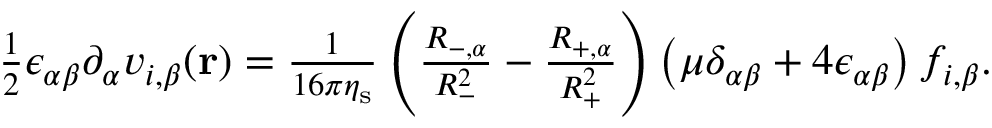<formula> <loc_0><loc_0><loc_500><loc_500>\begin{array} { r } { \frac { 1 } { 2 } \epsilon _ { \alpha \beta } \partial _ { \alpha } v _ { i , \beta } ( r ) = \frac { 1 } { 1 6 \pi \eta _ { s } } \left ( \frac { R _ { - , \alpha } } { R _ { - } ^ { 2 } } - \frac { R _ { + , \alpha } } { R _ { + } ^ { 2 } } \right ) \left ( \mu \delta _ { \alpha \beta } + 4 \epsilon _ { \alpha \beta } \right ) f _ { i , \beta } . } \end{array}</formula> 